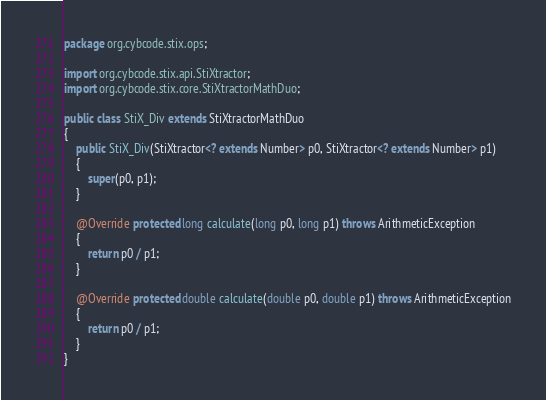<code> <loc_0><loc_0><loc_500><loc_500><_Java_>package org.cybcode.stix.ops;

import org.cybcode.stix.api.StiXtractor;
import org.cybcode.stix.core.StiXtractorMathDuo;

public class StiX_Div extends StiXtractorMathDuo
{
	public StiX_Div(StiXtractor<? extends Number> p0, StiXtractor<? extends Number> p1)
	{
		super(p0, p1);
	}

	@Override protected long calculate(long p0, long p1) throws ArithmeticException
	{
		return p0 / p1;
	}

	@Override protected double calculate(double p0, double p1) throws ArithmeticException
	{
		return p0 / p1;
	}
}</code> 